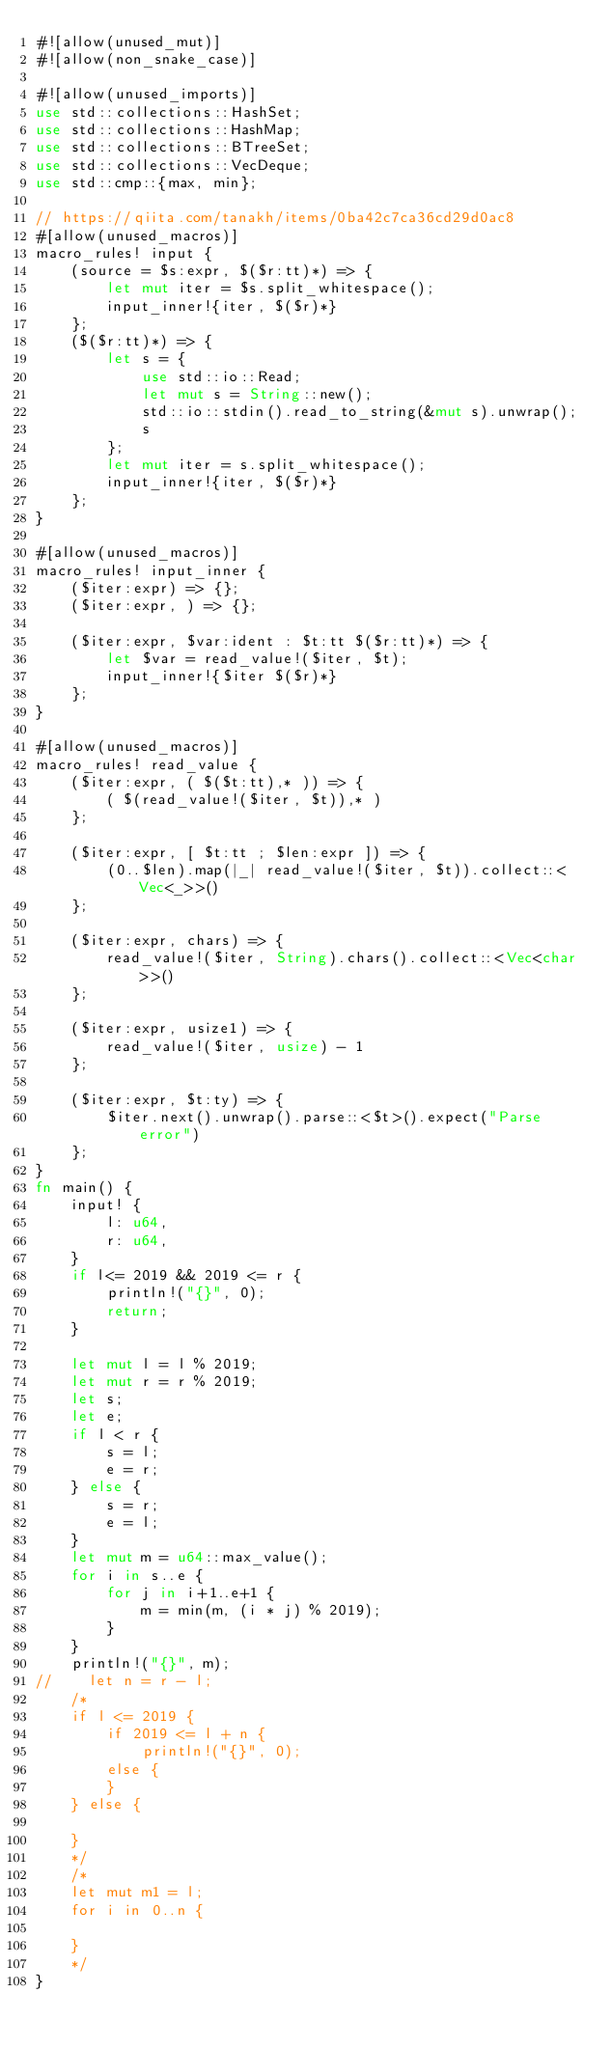Convert code to text. <code><loc_0><loc_0><loc_500><loc_500><_Rust_>#![allow(unused_mut)]
#![allow(non_snake_case)]

#![allow(unused_imports)]
use std::collections::HashSet;
use std::collections::HashMap;
use std::collections::BTreeSet;
use std::collections::VecDeque;
use std::cmp::{max, min};

// https://qiita.com/tanakh/items/0ba42c7ca36cd29d0ac8
#[allow(unused_macros)]
macro_rules! input {
    (source = $s:expr, $($r:tt)*) => {
        let mut iter = $s.split_whitespace();
        input_inner!{iter, $($r)*}
    };
    ($($r:tt)*) => {
        let s = {
            use std::io::Read;
            let mut s = String::new();
            std::io::stdin().read_to_string(&mut s).unwrap();
            s
        };
        let mut iter = s.split_whitespace();
        input_inner!{iter, $($r)*}
    };
}

#[allow(unused_macros)]
macro_rules! input_inner {
    ($iter:expr) => {};
    ($iter:expr, ) => {};

    ($iter:expr, $var:ident : $t:tt $($r:tt)*) => {
        let $var = read_value!($iter, $t);
        input_inner!{$iter $($r)*}
    };
}

#[allow(unused_macros)]
macro_rules! read_value {
    ($iter:expr, ( $($t:tt),* )) => {
        ( $(read_value!($iter, $t)),* )
    };

    ($iter:expr, [ $t:tt ; $len:expr ]) => {
        (0..$len).map(|_| read_value!($iter, $t)).collect::<Vec<_>>()
    };

    ($iter:expr, chars) => {
        read_value!($iter, String).chars().collect::<Vec<char>>()
    };

    ($iter:expr, usize1) => {
        read_value!($iter, usize) - 1
    };

    ($iter:expr, $t:ty) => {
        $iter.next().unwrap().parse::<$t>().expect("Parse error")
    };
}
fn main() {
    input! {
        l: u64,
        r: u64,
    }
    if l<= 2019 && 2019 <= r {
        println!("{}", 0);
        return;
    }

    let mut l = l % 2019;
    let mut r = r % 2019;
    let s;
    let e;
    if l < r {
        s = l;
        e = r;
    } else {
        s = r;
        e = l;
    }
    let mut m = u64::max_value();
    for i in s..e {
        for j in i+1..e+1 {
            m = min(m, (i * j) % 2019);
        }
    }
    println!("{}", m);
//    let n = r - l;
    /*
    if l <= 2019 {
        if 2019 <= l + n {
            println!("{}", 0);
        else {
        }
    } else {

    }
    */
    /*
    let mut m1 = l;
    for i in 0..n {

    }
    */
}</code> 